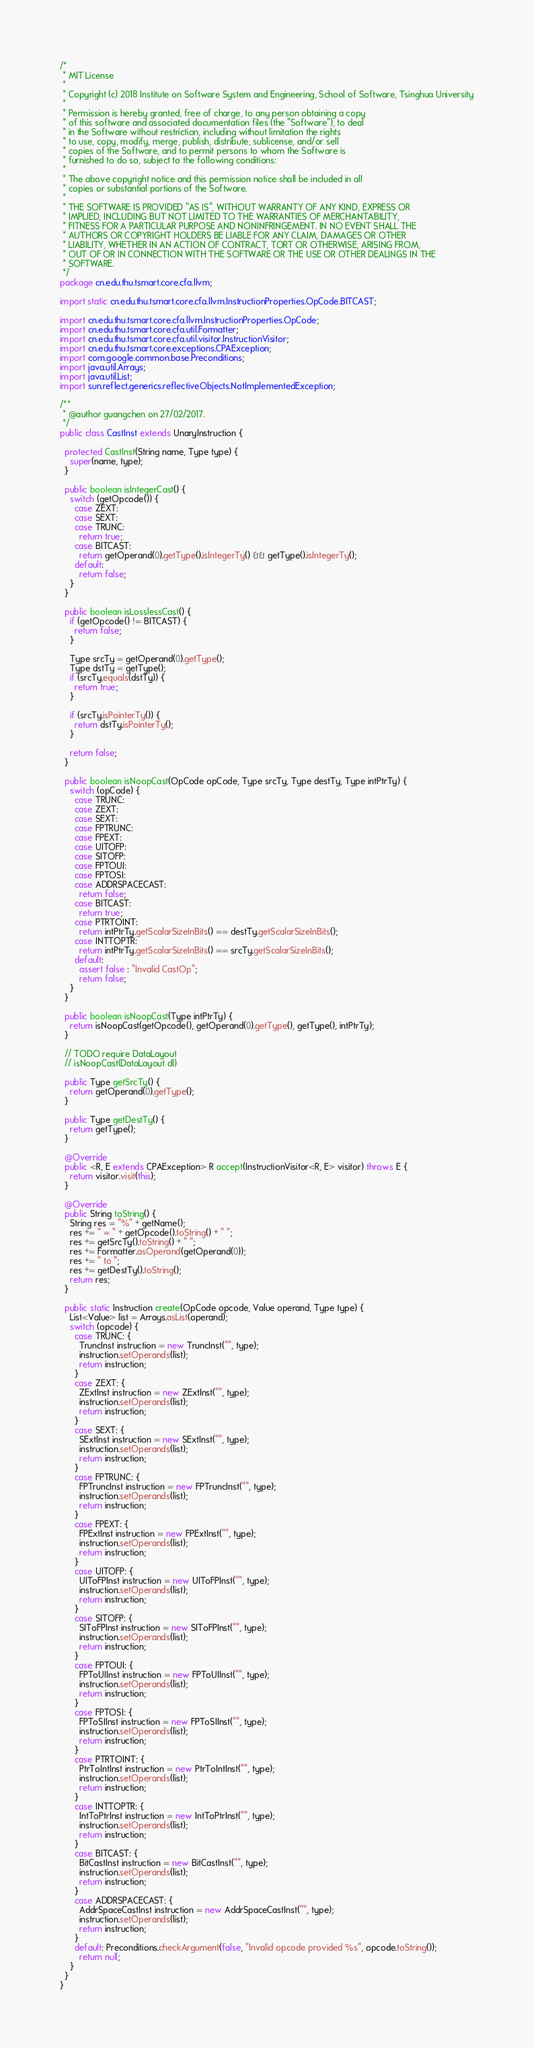Convert code to text. <code><loc_0><loc_0><loc_500><loc_500><_Java_>/*
 * MIT License
 *
 * Copyright (c) 2018 Institute on Software System and Engineering, School of Software, Tsinghua University
 *
 * Permission is hereby granted, free of charge, to any person obtaining a copy
 * of this software and associated documentation files (the "Software"), to deal
 * in the Software without restriction, including without limitation the rights
 * to use, copy, modify, merge, publish, distribute, sublicense, and/or sell
 * copies of the Software, and to permit persons to whom the Software is
 * furnished to do so, subject to the following conditions:
 *
 * The above copyright notice and this permission notice shall be included in all
 * copies or substantial portions of the Software.
 *
 * THE SOFTWARE IS PROVIDED "AS IS", WITHOUT WARRANTY OF ANY KIND, EXPRESS OR
 * IMPLIED, INCLUDING BUT NOT LIMITED TO THE WARRANTIES OF MERCHANTABILITY,
 * FITNESS FOR A PARTICULAR PURPOSE AND NONINFRINGEMENT. IN NO EVENT SHALL THE
 * AUTHORS OR COPYRIGHT HOLDERS BE LIABLE FOR ANY CLAIM, DAMAGES OR OTHER
 * LIABILITY, WHETHER IN AN ACTION OF CONTRACT, TORT OR OTHERWISE, ARISING FROM,
 * OUT OF OR IN CONNECTION WITH THE SOFTWARE OR THE USE OR OTHER DEALINGS IN THE
 * SOFTWARE.
 */
package cn.edu.thu.tsmart.core.cfa.llvm;

import static cn.edu.thu.tsmart.core.cfa.llvm.InstructionProperties.OpCode.BITCAST;

import cn.edu.thu.tsmart.core.cfa.llvm.InstructionProperties.OpCode;
import cn.edu.thu.tsmart.core.cfa.util.Formatter;
import cn.edu.thu.tsmart.core.cfa.util.visitor.InstructionVisitor;
import cn.edu.thu.tsmart.core.exceptions.CPAException;
import com.google.common.base.Preconditions;
import java.util.Arrays;
import java.util.List;
import sun.reflect.generics.reflectiveObjects.NotImplementedException;

/**
 * @author guangchen on 27/02/2017.
 */
public class CastInst extends UnaryInstruction {

  protected CastInst(String name, Type type) {
    super(name, type);
  }

  public boolean isIntegerCast() {
    switch (getOpcode()) {
      case ZEXT:
      case SEXT:
      case TRUNC:
        return true;
      case BITCAST:
        return getOperand(0).getType().isIntegerTy() && getType().isIntegerTy();
      default:
        return false;
    }
  }

  public boolean isLosslessCast() {
    if (getOpcode() != BITCAST) {
      return false;
    }

    Type srcTy = getOperand(0).getType();
    Type dstTy = getType();
    if (srcTy.equals(dstTy)) {
      return true;
    }

    if (srcTy.isPointerTy()) {
      return dstTy.isPointerTy();
    }

    return false;
  }

  public boolean isNoopCast(OpCode opCode, Type srcTy, Type destTy, Type intPtrTy) {
    switch (opCode) {
      case TRUNC:
      case ZEXT:
      case SEXT:
      case FPTRUNC:
      case FPEXT:
      case UITOFP:
      case SITOFP:
      case FPTOUI:
      case FPTOSI:
      case ADDRSPACECAST:
        return false;
      case BITCAST:
        return true;
      case PTRTOINT:
        return intPtrTy.getScalarSizeInBits() == destTy.getScalarSizeInBits();
      case INTTOPTR:
        return intPtrTy.getScalarSizeInBits() == srcTy.getScalarSizeInBits();
      default:
        assert false : "Invalid CastOp";
        return false;
    }
  }

  public boolean isNoopCast(Type intPtrTy) {
    return isNoopCast(getOpcode(), getOperand(0).getType(), getType(), intPtrTy);
  }

  // TODO require DataLayout
  // isNoopCast(DataLayout dl)

  public Type getSrcTy() {
    return getOperand(0).getType();
  }

  public Type getDestTy() {
    return getType();
  }

  @Override
  public <R, E extends CPAException> R accept(InstructionVisitor<R, E> visitor) throws E {
    return visitor.visit(this);
  }

  @Override
  public String toString() {
    String res = "%" + getName();
    res += " = " + getOpcode().toString() + " ";
    res += getSrcTy().toString() + " ";
    res += Formatter.asOperand(getOperand(0));
    res += " to ";
    res += getDestTy().toString();
    return res;
  }

  public static Instruction create(OpCode opcode, Value operand, Type type) {
    List<Value> list = Arrays.asList(operand);
    switch (opcode) {
      case TRUNC: {
        TruncInst instruction = new TruncInst("", type);
        instruction.setOperands(list);
        return instruction;
      }
      case ZEXT: {
        ZExtInst instruction = new ZExtInst("", type);
        instruction.setOperands(list);
        return instruction;
      }
      case SEXT: {
        SExtInst instruction = new SExtInst("", type);
        instruction.setOperands(list);
        return instruction;
      }
      case FPTRUNC: {
        FPTruncInst instruction = new FPTruncInst("", type);
        instruction.setOperands(list);
        return instruction;
      }
      case FPEXT: {
        FPExtInst instruction = new FPExtInst("", type);
        instruction.setOperands(list);
        return instruction;
      }
      case UITOFP: {
        UIToFPInst instruction = new UIToFPInst("", type);
        instruction.setOperands(list);
        return instruction;
      }
      case SITOFP: {
        SIToFPInst instruction = new SIToFPInst("", type);
        instruction.setOperands(list);
        return instruction;
      }
      case FPTOUI: {
        FPToUIInst instruction = new FPToUIInst("", type);
        instruction.setOperands(list);
        return instruction;
      }
      case FPTOSI: {
        FPToSIInst instruction = new FPToSIInst("", type);
        instruction.setOperands(list);
        return instruction;
      }
      case PTRTOINT: {
        PtrToIntInst instruction = new PtrToIntInst("", type);
        instruction.setOperands(list);
        return instruction;
      }
      case INTTOPTR: {
        IntToPtrInst instruction = new IntToPtrInst("", type);
        instruction.setOperands(list);
        return instruction;
      }
      case BITCAST: {
        BitCastInst instruction = new BitCastInst("", type);
        instruction.setOperands(list);
        return instruction;
      }
      case ADDRSPACECAST: {
        AddrSpaceCastInst instruction = new AddrSpaceCastInst("", type);
        instruction.setOperands(list);
        return instruction;
      }
      default: Preconditions.checkArgument(false, "Invalid opcode provided %s", opcode.toString());
        return null;
    }
  }
}
</code> 